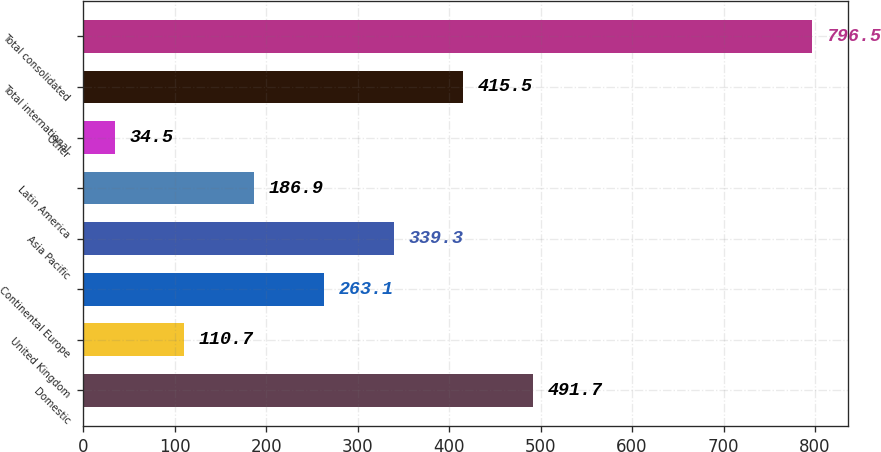Convert chart. <chart><loc_0><loc_0><loc_500><loc_500><bar_chart><fcel>Domestic<fcel>United Kingdom<fcel>Continental Europe<fcel>Asia Pacific<fcel>Latin America<fcel>Other<fcel>Total international<fcel>Total consolidated<nl><fcel>491.7<fcel>110.7<fcel>263.1<fcel>339.3<fcel>186.9<fcel>34.5<fcel>415.5<fcel>796.5<nl></chart> 